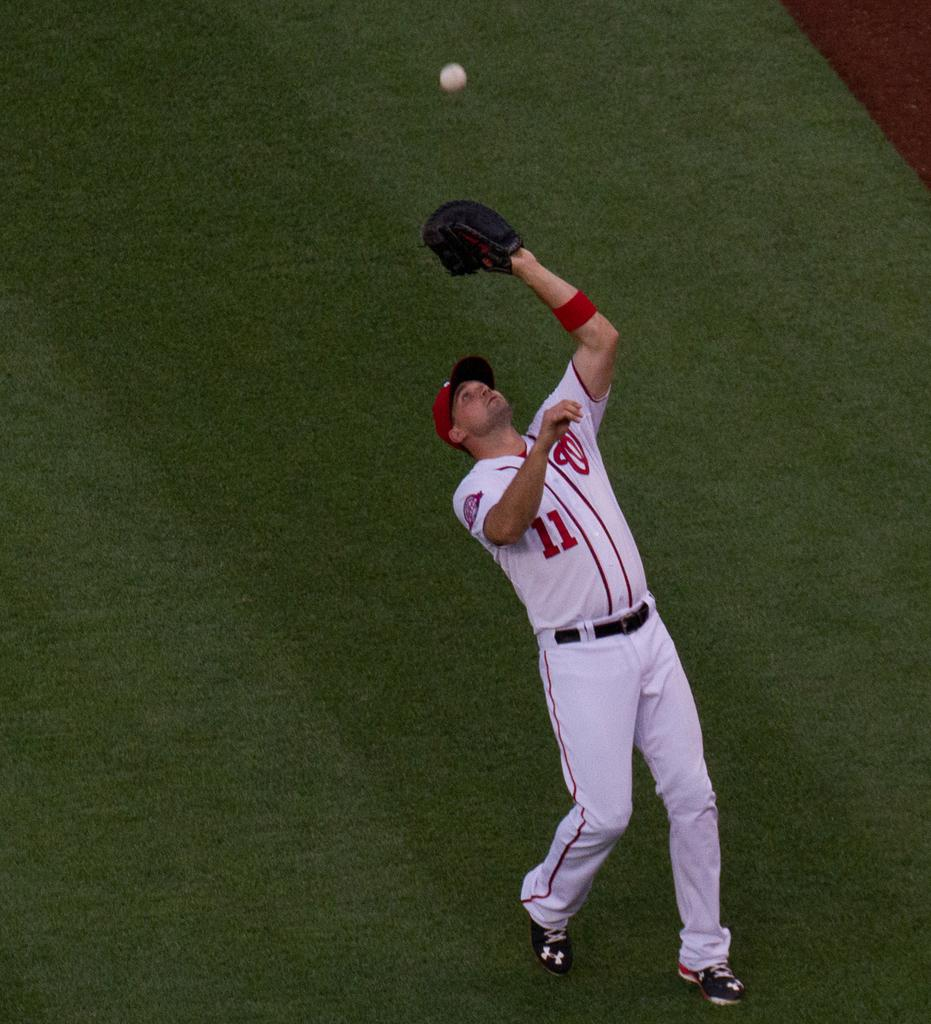Provide a one-sentence caption for the provided image. Number 11 from the Washington Nationals catches a ball in the outfield. 